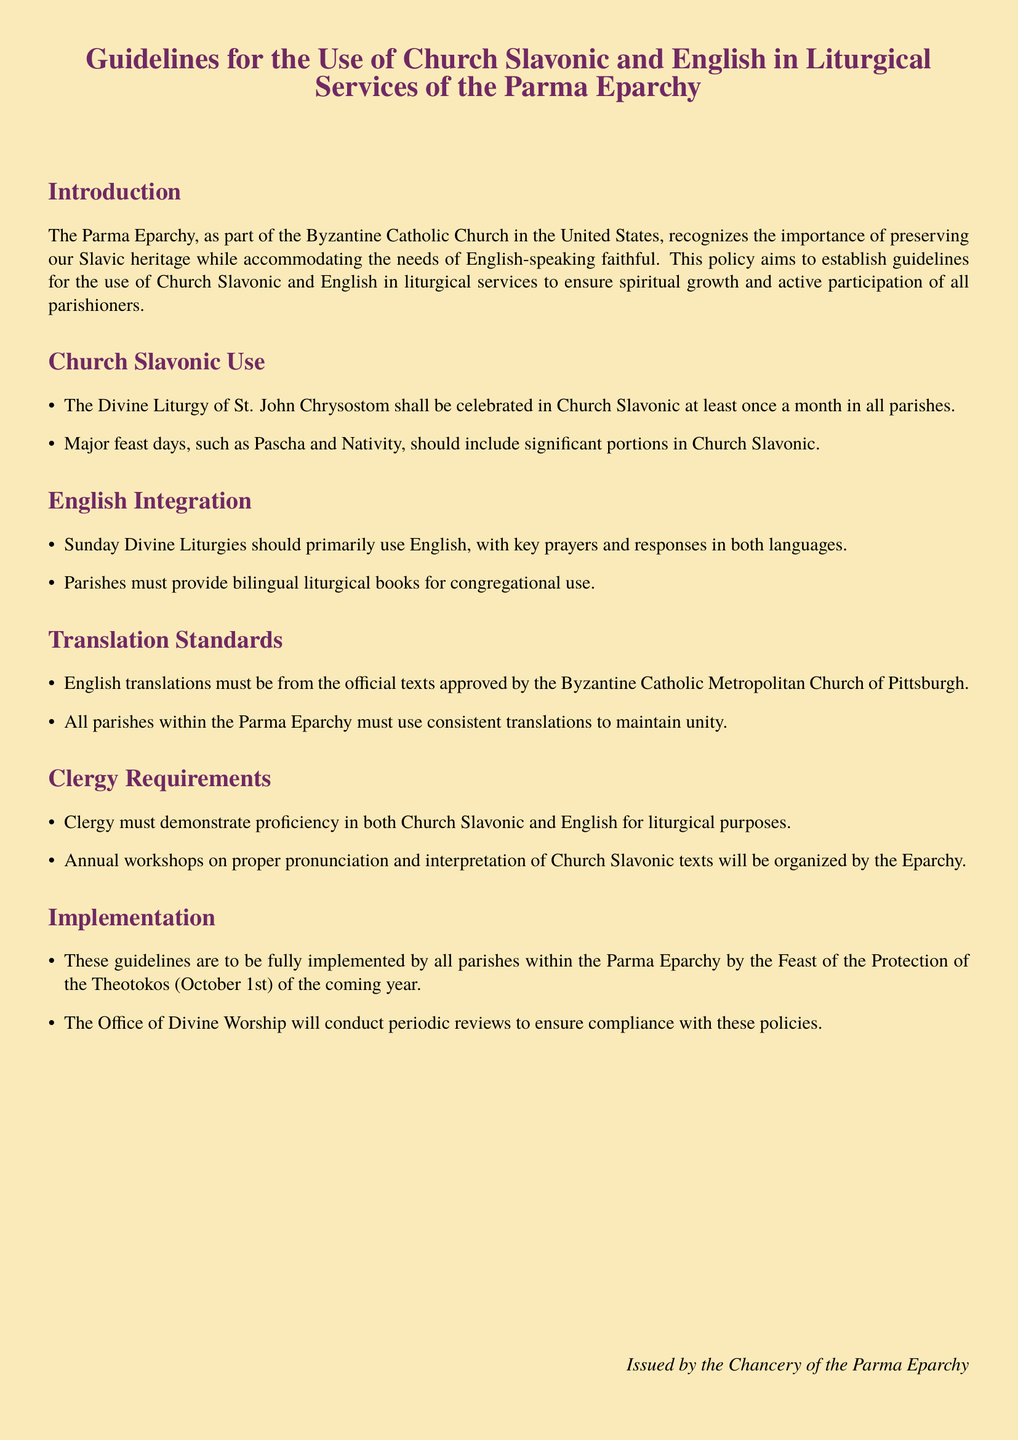What is the main purpose of the policy? The main purpose of the policy is to establish guidelines for the use of Church Slavonic and English in liturgical services to ensure spiritual growth and active participation of all parishioners.
Answer: to establish guidelines How often should the Divine Liturgy in Church Slavonic be celebrated? The document states that the Divine Liturgy of St. John Chrysostom shall be celebrated in Church Slavonic at least once a month in all parishes.
Answer: at least once a month When is the deadline for implementing these guidelines? The guidelines are to be fully implemented by all parishes within the Parma Eparchy by the Feast of the Protection of the Theotokos (October 1st) of the coming year.
Answer: October 1st Who must approve the English translations used in liturgical services? The document specifies that English translations must be from the official texts approved by the Byzantine Catholic Metropolitan Church of Pittsburgh.
Answer: Byzantine Catholic Metropolitan Church of Pittsburgh What is required of clergy regarding language proficiency? The policy states that clergy must demonstrate proficiency in both Church Slavonic and English for liturgical purposes.
Answer: proficiency in both languages What will the Office of Divine Worship do according to the document? The Office of Divine Worship will conduct periodic reviews to ensure compliance with these policies.
Answer: conduct periodic reviews What type of liturgical books must parishes provide? Parishes must provide bilingual liturgical books for congregational use.
Answer: bilingual liturgical books What is one major feast day mentioned in the document? The document refers to significant feast days that should include portions in Church Slavonic, such as Pascha and Nativity.
Answer: Pascha 